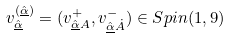Convert formula to latex. <formula><loc_0><loc_0><loc_500><loc_500>v _ { \hat { \underline { \alpha } } } ^ { ( { \hat { \underline { \alpha } } } ) } = ( v ^ { + } _ { \hat { \underline { \alpha } } A } , v ^ { - } _ { \hat { \underline { \alpha } } \dot { A } } ) \in S p i n ( 1 , 9 )</formula> 